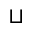<formula> <loc_0><loc_0><loc_500><loc_500>\sqcup</formula> 